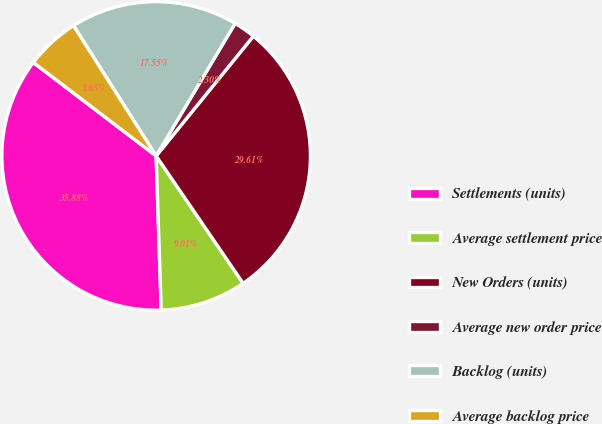Convert chart to OTSL. <chart><loc_0><loc_0><loc_500><loc_500><pie_chart><fcel>Settlements (units)<fcel>Average settlement price<fcel>New Orders (units)<fcel>Average new order price<fcel>Backlog (units)<fcel>Average backlog price<nl><fcel>35.88%<fcel>9.01%<fcel>29.61%<fcel>2.3%<fcel>17.55%<fcel>5.65%<nl></chart> 